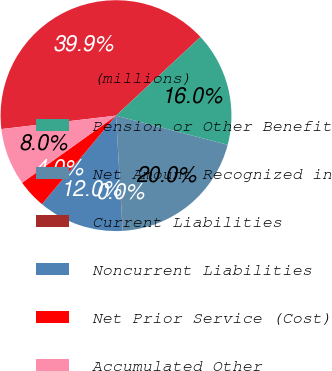<chart> <loc_0><loc_0><loc_500><loc_500><pie_chart><fcel>(millions)<fcel>Pension or Other Benefit<fcel>Net Amount Recognized in<fcel>Current Liabilities<fcel>Noncurrent Liabilities<fcel>Net Prior Service (Cost)<fcel>Accumulated Other<nl><fcel>39.93%<fcel>16.0%<fcel>19.98%<fcel>0.04%<fcel>12.01%<fcel>4.03%<fcel>8.02%<nl></chart> 